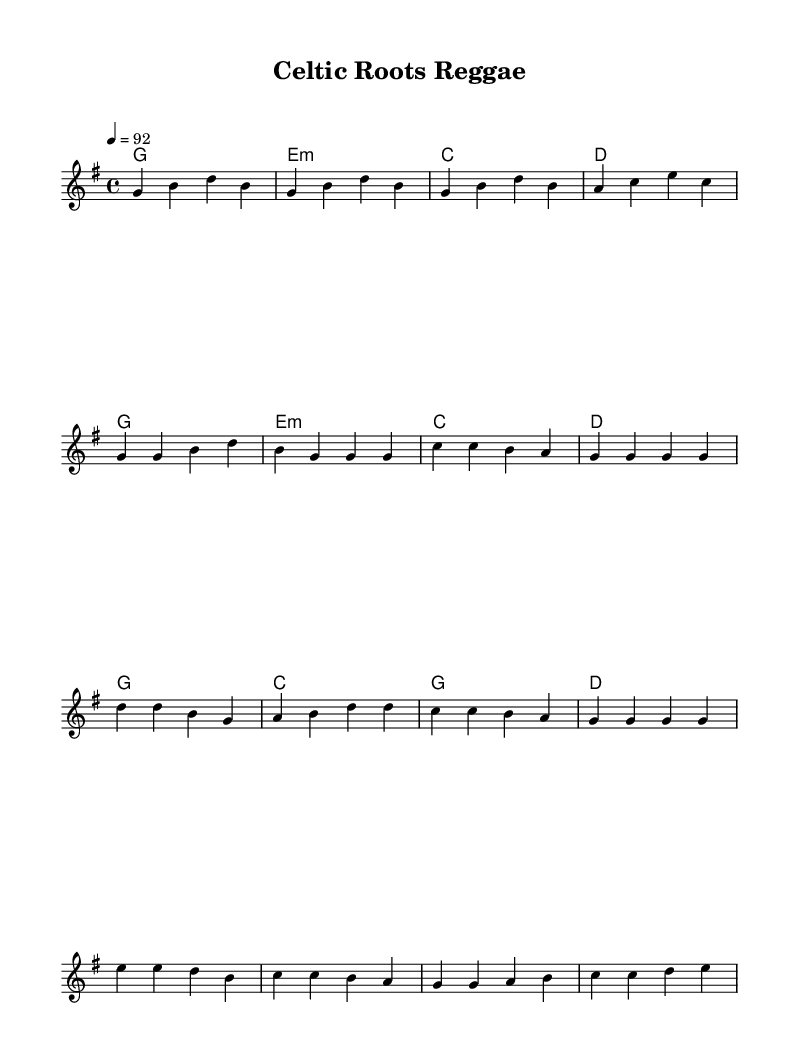What is the tempo marking of this music? The tempo marking is indicated at the beginning of the score with the notation "4 = 92," which means there are four beats per measure, and the quarter note equals 92 beats per minute.
Answer: 92 What is the key signature of this piece? The key signature is indicated by the sharp on the staff; in this case, it has one sharp, which corresponds to G major.
Answer: G major How many measures are in the chorus section? To find the measures in the chorus, we need to count the distinct groups of notes in the chorus section. There are four groups of notes in the chorus, making it four measures.
Answer: 4 What chord is played at the start of the piece? The first chord in the harmony section is labeled with the letter G, indicating it is the G major chord played at the start of the piece.
Answer: G What is the time signature of this music? The time signature is shown at the beginning of the score with the notation "4/4," indicating there are four beats per measure and it's a common time signature.
Answer: 4/4 Which two styles are blended in this piece? The piece blends traditional European folk melodies, often characterized by specific folk elements, with rhythms commonly used in Jamaican reggae music, creating a fusion style.
Answer: European folk and reggae 